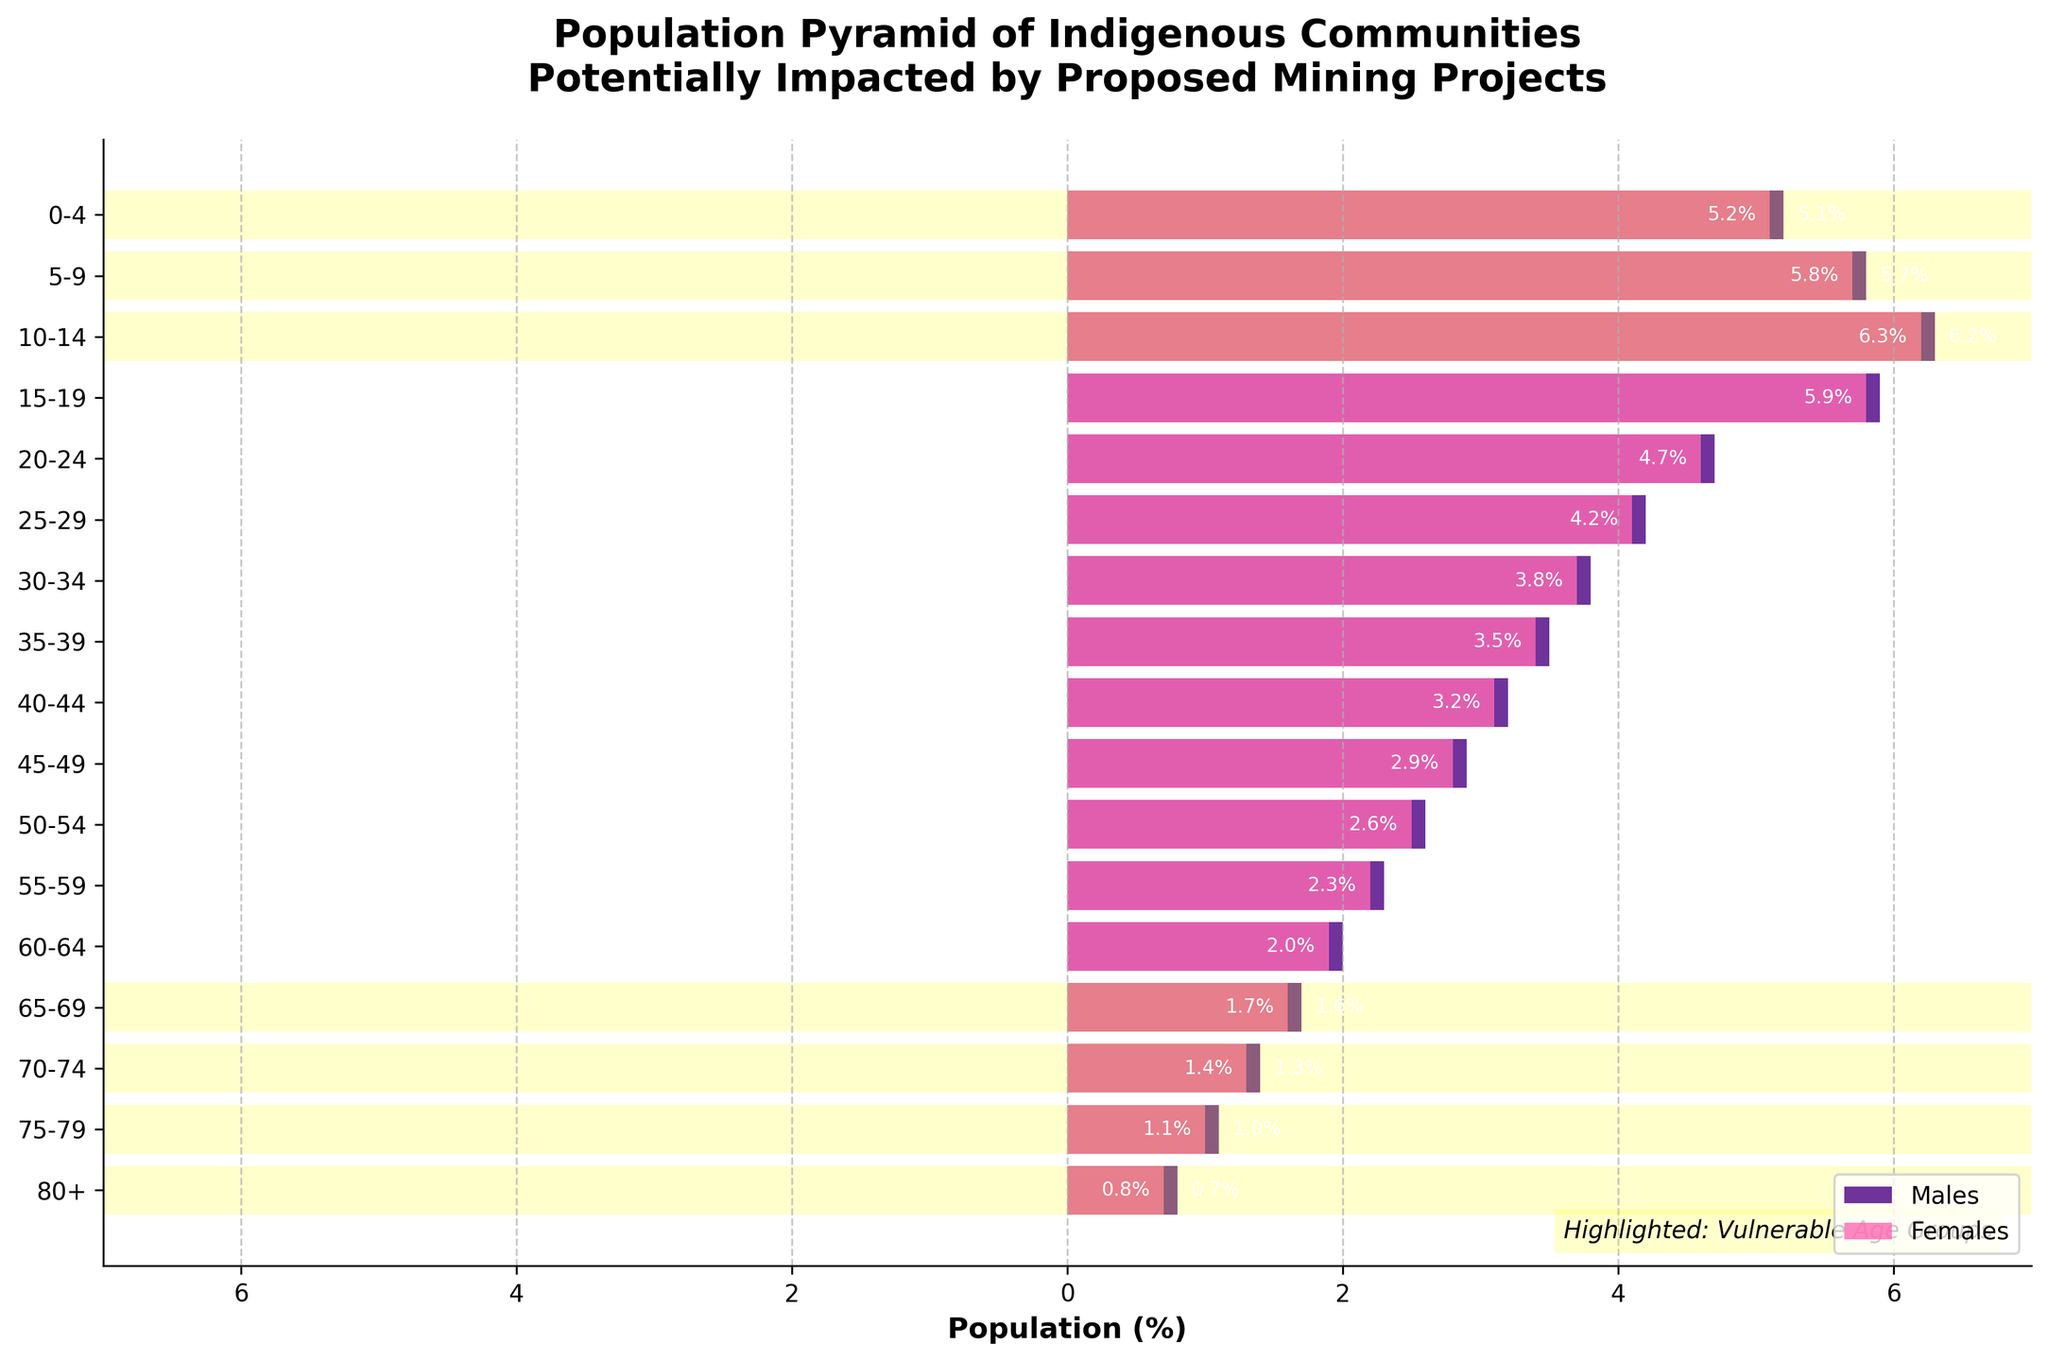What is the title of the figure? The title is prominently displayed at the top of the figure. It reads “Population Pyramid of Indigenous Communities Potentially Impacted by Proposed Mining Projects.” This information is found by looking at the top central part of the figure.
Answer: Population Pyramid of Indigenous Communities Potentially Impacted by Proposed Mining Projects How many age groups are represented in the figure? You can count the number of labels on the y-axis representing different age groups. The figure shows labels from "0-4" to "80+", which are 17 age groups in total.
Answer: 17 Which age group has the highest percentage for males in the population? By comparing the lengths of the bars on the left (representing males), the age group "10-14" has the longest bar, indicating the highest percentage, which is 6.3%. This is found by observing the left side of the figure.
Answer: 10-14 What are the percentages for males and females in the "20-24" age group? Look at the horizontal bars corresponding to the "20-24" age group. The lengths of the bars indicate that males have a percentage of 4.7%, and females have a percentage of 4.6%. This is found by observing the bars for this age group.
Answer: Males: 4.7%, Females: 4.6% Which vulnerable age group has the lowest percentage for females? By identifying the highlighted "vulnerable age groups" and comparing the lengths of their bars for females, the "80+" group has the shortest bar for females, with a percentage of 0.7%. This is found by looking at the highlighted groups and observing the female bars.
Answer: 80+ Compare the total male population percentages for the age groups "0-4" and "10-14". Which one is greater and by how much? Calculate the percentage difference by subtracting the value for "0-4" (5.2%) from "10-14" (6.3%). 6.3% - 5.2% = 1.1%. This involves comparing the lengths of the bars for these age groups and performing a subtraction.
Answer: 10-14, by 1.1% Are there any age groups where the female percentage is higher than the male percentage? If so, name one. By visually comparing the lengths of the bars for males and females across all age groups, it's noticeable that for the age group "80+", females have a higher percentage (0.7%) compared to males (0.8%).
Answer: 80+ What distinguishes the vulnerable age groups in the figure? The vulnerable age groups are highlighted with a yellow background, which makes them stand out from the non-vulnerable groups. This differentiation can be observed as yellow spans over specific groups on the y-axis.
Answer: Highlighted with a yellow background Which age group has nearly equal male and female percentages? By comparing the lengths of the male and female bars across all age groups, the "0-4" age group shows very close percentages with males at 5.2% and females at 5.1%. This comparison can be seen visually.
Answer: 0-4 What is the cumulative percentage of males for the vulnerable age groups "70-74", "75-79", and "80+"? To find the cumulative percentage, sum the values for males in these age groups: 1.4% (70-74) + 1.1% (75-79) + 0.8% (80+) = 3.3%. This requires summing the percentages for these specific age groups.
Answer: 3.3% 